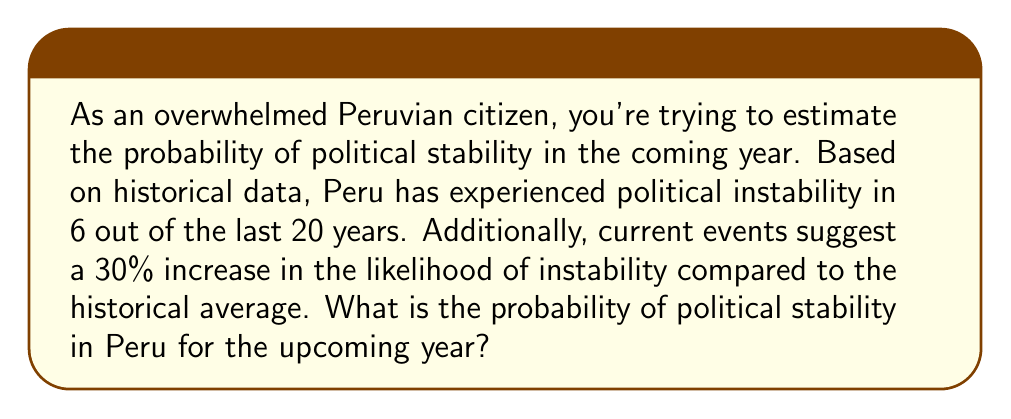Teach me how to tackle this problem. Let's approach this problem step by step:

1) First, let's calculate the historical probability of instability:
   $P(\text{instability}) = \frac{6}{20} = 0.3$ or 30%

2) This means the historical probability of stability is:
   $P(\text{stability}) = 1 - P(\text{instability}) = 1 - 0.3 = 0.7$ or 70%

3) Now, we're told that current events increase the likelihood of instability by 30% compared to the historical average. This means we need to increase the probability of instability by 30%:
   
   New $P(\text{instability}) = 0.3 \times (1 + 0.3) = 0.3 \times 1.3 = 0.39$ or 39%

4) Therefore, the new probability of stability is:
   New $P(\text{stability}) = 1 - \text{New }P(\text{instability}) = 1 - 0.39 = 0.61$ or 61%

So, the probability of political stability in Peru for the upcoming year is 0.61 or 61%.
Answer: 0.61 or 61% 